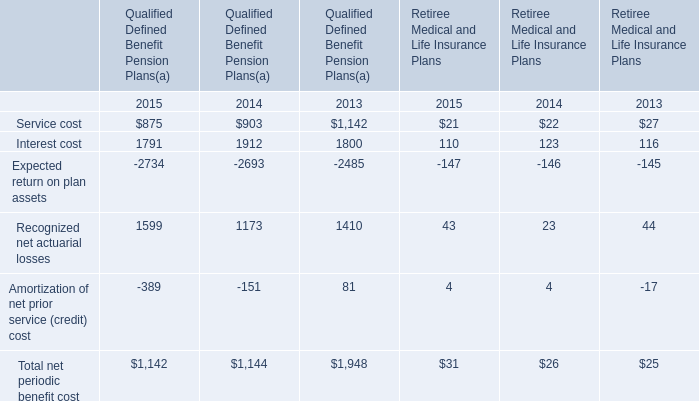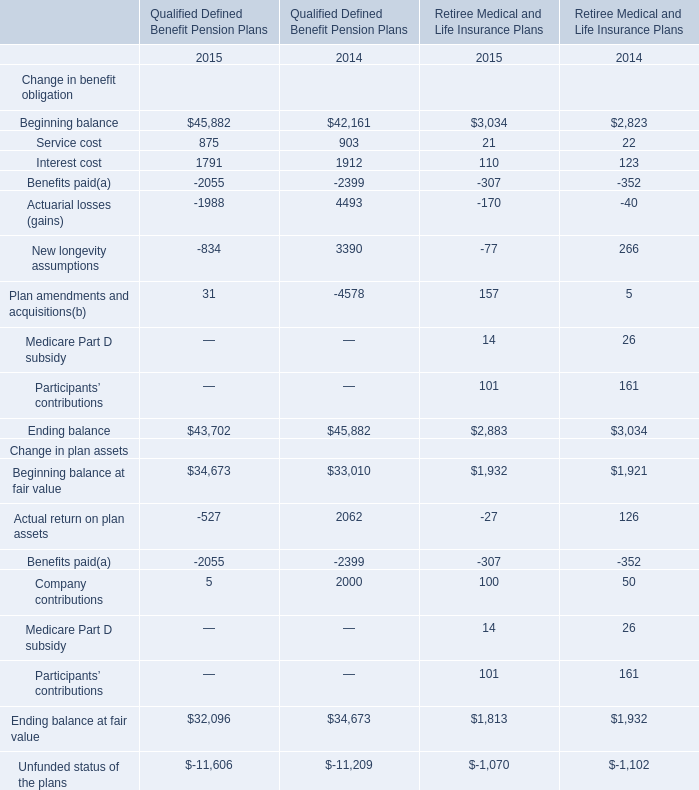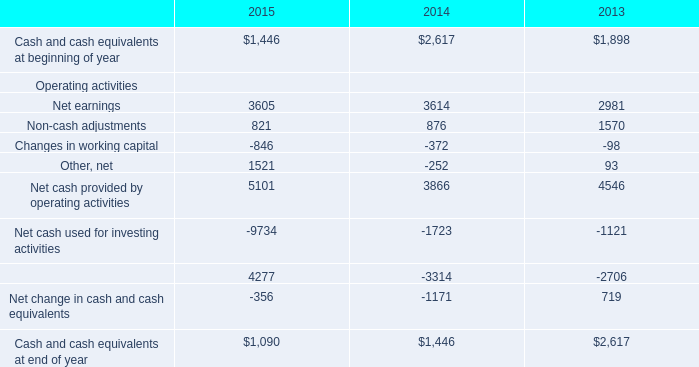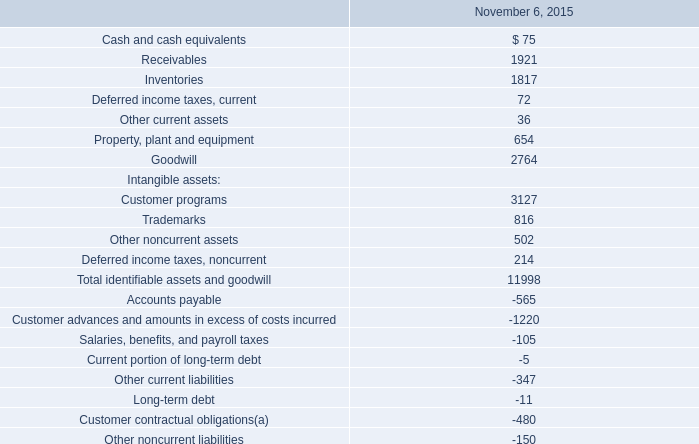In which section the sum of Interest cost has the highest value? 
Answer: Qualified Defined Benefit Pension Plans in 2004. 